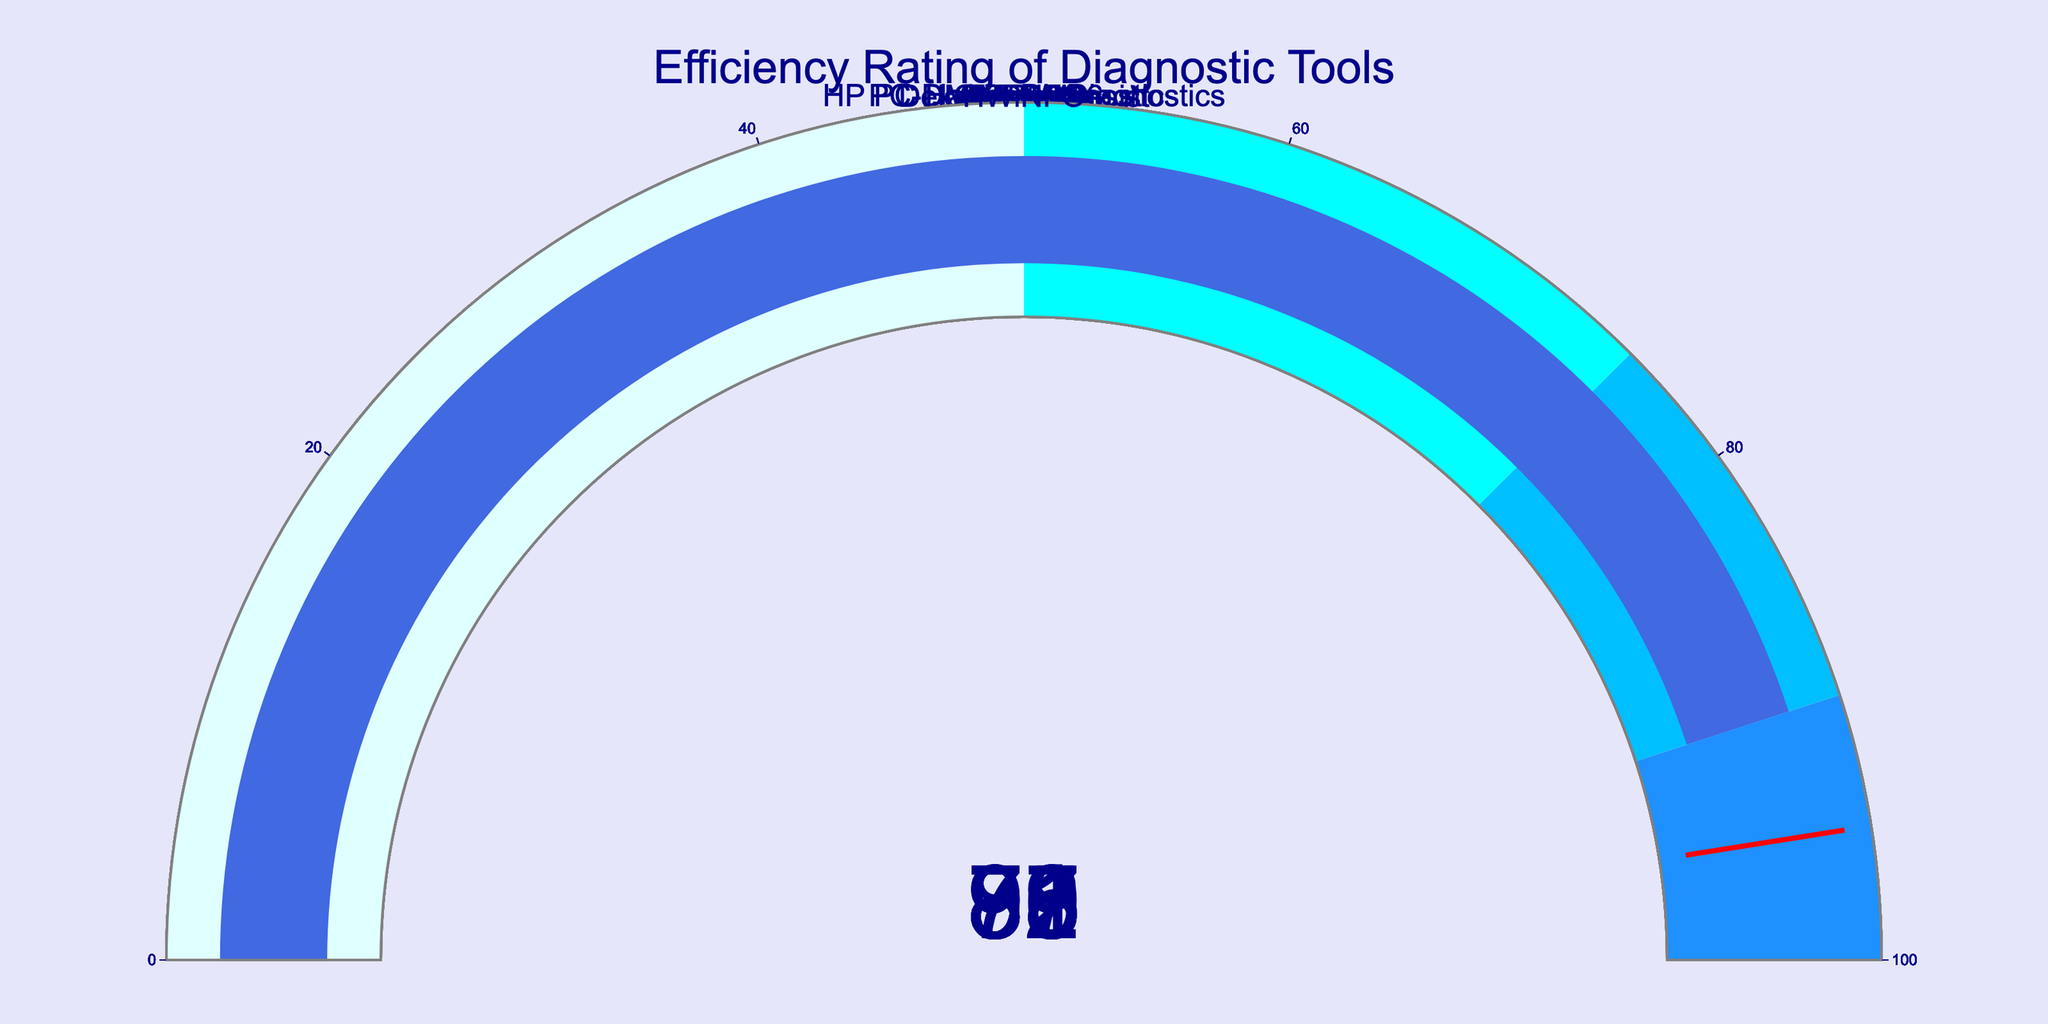What is the title of the figure? The title of the figure can be found at the top center of the plot. It is written in a large font size.
Answer: Efficiency Rating of Diagnostic Tools How many diagnostic tools are displayed in the figure? You need to count the number of gauge charts in the figure.
Answer: 10 Which diagnostic tool has the highest efficiency rating? Look for the gauge chart with the highest number shown on it. In this case, it is 95, which corresponds to the tool "MemTest86".
Answer: MemTest86 Which diagnostic tool has the lowest efficiency rating? Identify the smallest number displayed on the gauges to find the lowest efficiency rating. It is 78, corresponding to "GlassWire".
Answer: GlassWire What is the efficiency rating of AIDA64? Look for the gauge chart labeled "AIDA64" and note the number displayed on it.
Answer: 92 How much higher is the efficiency rating of MemTest86 compared to Dell SupportAssist? Find the values for MemTest86 (95) and Dell SupportAssist (79), and then subtract the latter from the former. 95 - 79 = 16.
Answer: 16 What is the average efficiency rating of all the diagnostic tools? Sum all the efficiency ratings (87+79+83+92+95+88+85+78+81+90=858) and divide by the number of tools (10). 858 / 10 = 85.8.
Answer: 85.8 How many diagnostic tools have an efficiency rating above 80? Count the number of gauges with numbers greater than 80: PC-Doctor Diagnostics, HP PC Hardware Diagnostics, AIDA64, MemTest86, Prime95, Furmark, CCleaner, HWiNFO. There are 8 tools.
Answer: 8 Which two diagnostic tools have the smallest difference in their efficiency ratings? Compare all pairs and find the one with the smallest difference. "PC-Doctor Diagnostics" (87) and "Prime95" (88) have a difference of 1.
Answer: PC-Doctor Diagnostics and Prime95 Are there any diagnostic tools with an efficiency rating in the range of 50-75? Check if any gauges fall within the 50-75 range. No gauges show numbers within this range.
Answer: No Which diagnostic tools' efficiency ratings fall within the "dodgerblue" segment of the gauge? Identify the tools with ratings between 90-100, which is the “dodgerblue” range. These tools are "MemTest86" and "HWiNFO".
Answer: MemTest86 and HWiNFO 